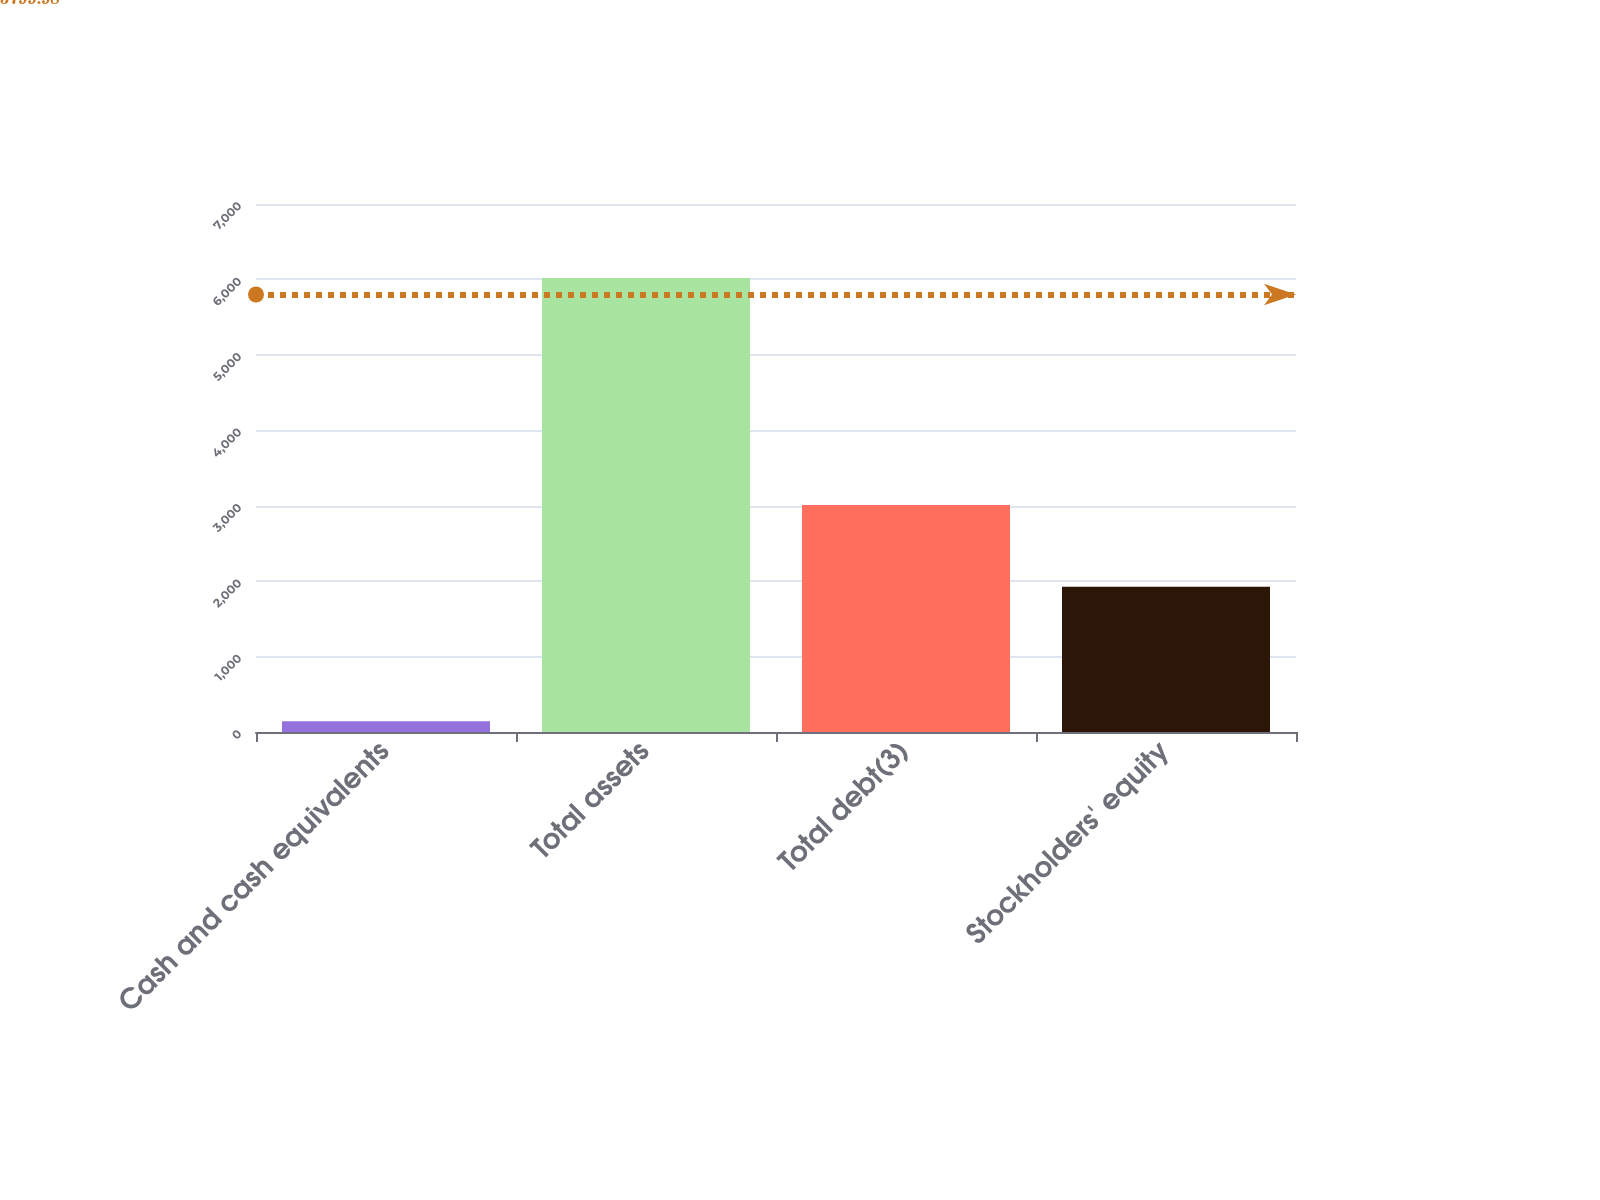Convert chart. <chart><loc_0><loc_0><loc_500><loc_500><bar_chart><fcel>Cash and cash equivalents<fcel>Total assets<fcel>Total debt(3)<fcel>Stockholders' equity<nl><fcel>142.3<fcel>6020.3<fcel>3008.8<fcel>1925.4<nl></chart> 